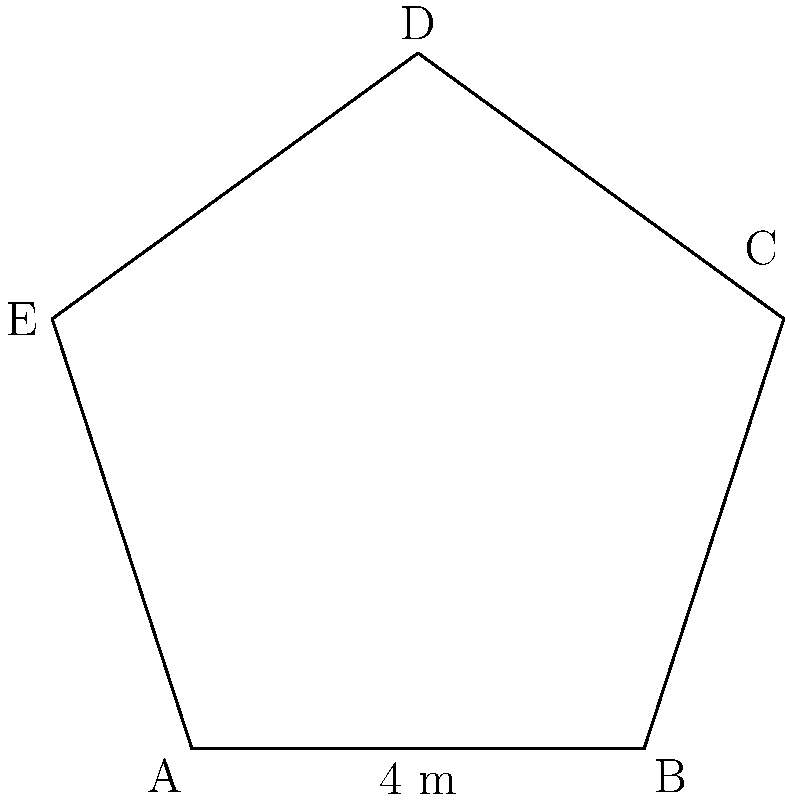In the pentagonal room of the historical archive building where documents from the Reformation era are stored, one side measures 4 meters. If the room is a regular pentagon, what is its total area in square meters? Round your answer to the nearest whole number. To find the area of a regular pentagon, we can follow these steps:

1) For a regular pentagon, the formula for area is:

   $$A = \frac{1}{4} \sqrt{25 + 10\sqrt{5}} \cdot s^2$$

   where $s$ is the length of one side.

2) We're given that one side is 4 meters, so $s = 4$.

3) Let's substitute this into our formula:

   $$A = \frac{1}{4} \sqrt{25 + 10\sqrt{5}} \cdot 4^2$$

4) Simplify inside the parentheses:

   $$A = \frac{1}{4} \sqrt{25 + 10\sqrt{5}} \cdot 16$$

5) Multiply:

   $$A = 4\sqrt{25 + 10\sqrt{5}}$$

6) Calculate the value under the square root:
   $25 + 10\sqrt{5} \approx 47.36$

7) Take the square root:
   $$A = 4\sqrt{47.36} \approx 27.52$$

8) Rounding to the nearest whole number:

   $$A \approx 28 \text{ m}^2$$
Answer: 28 m² 